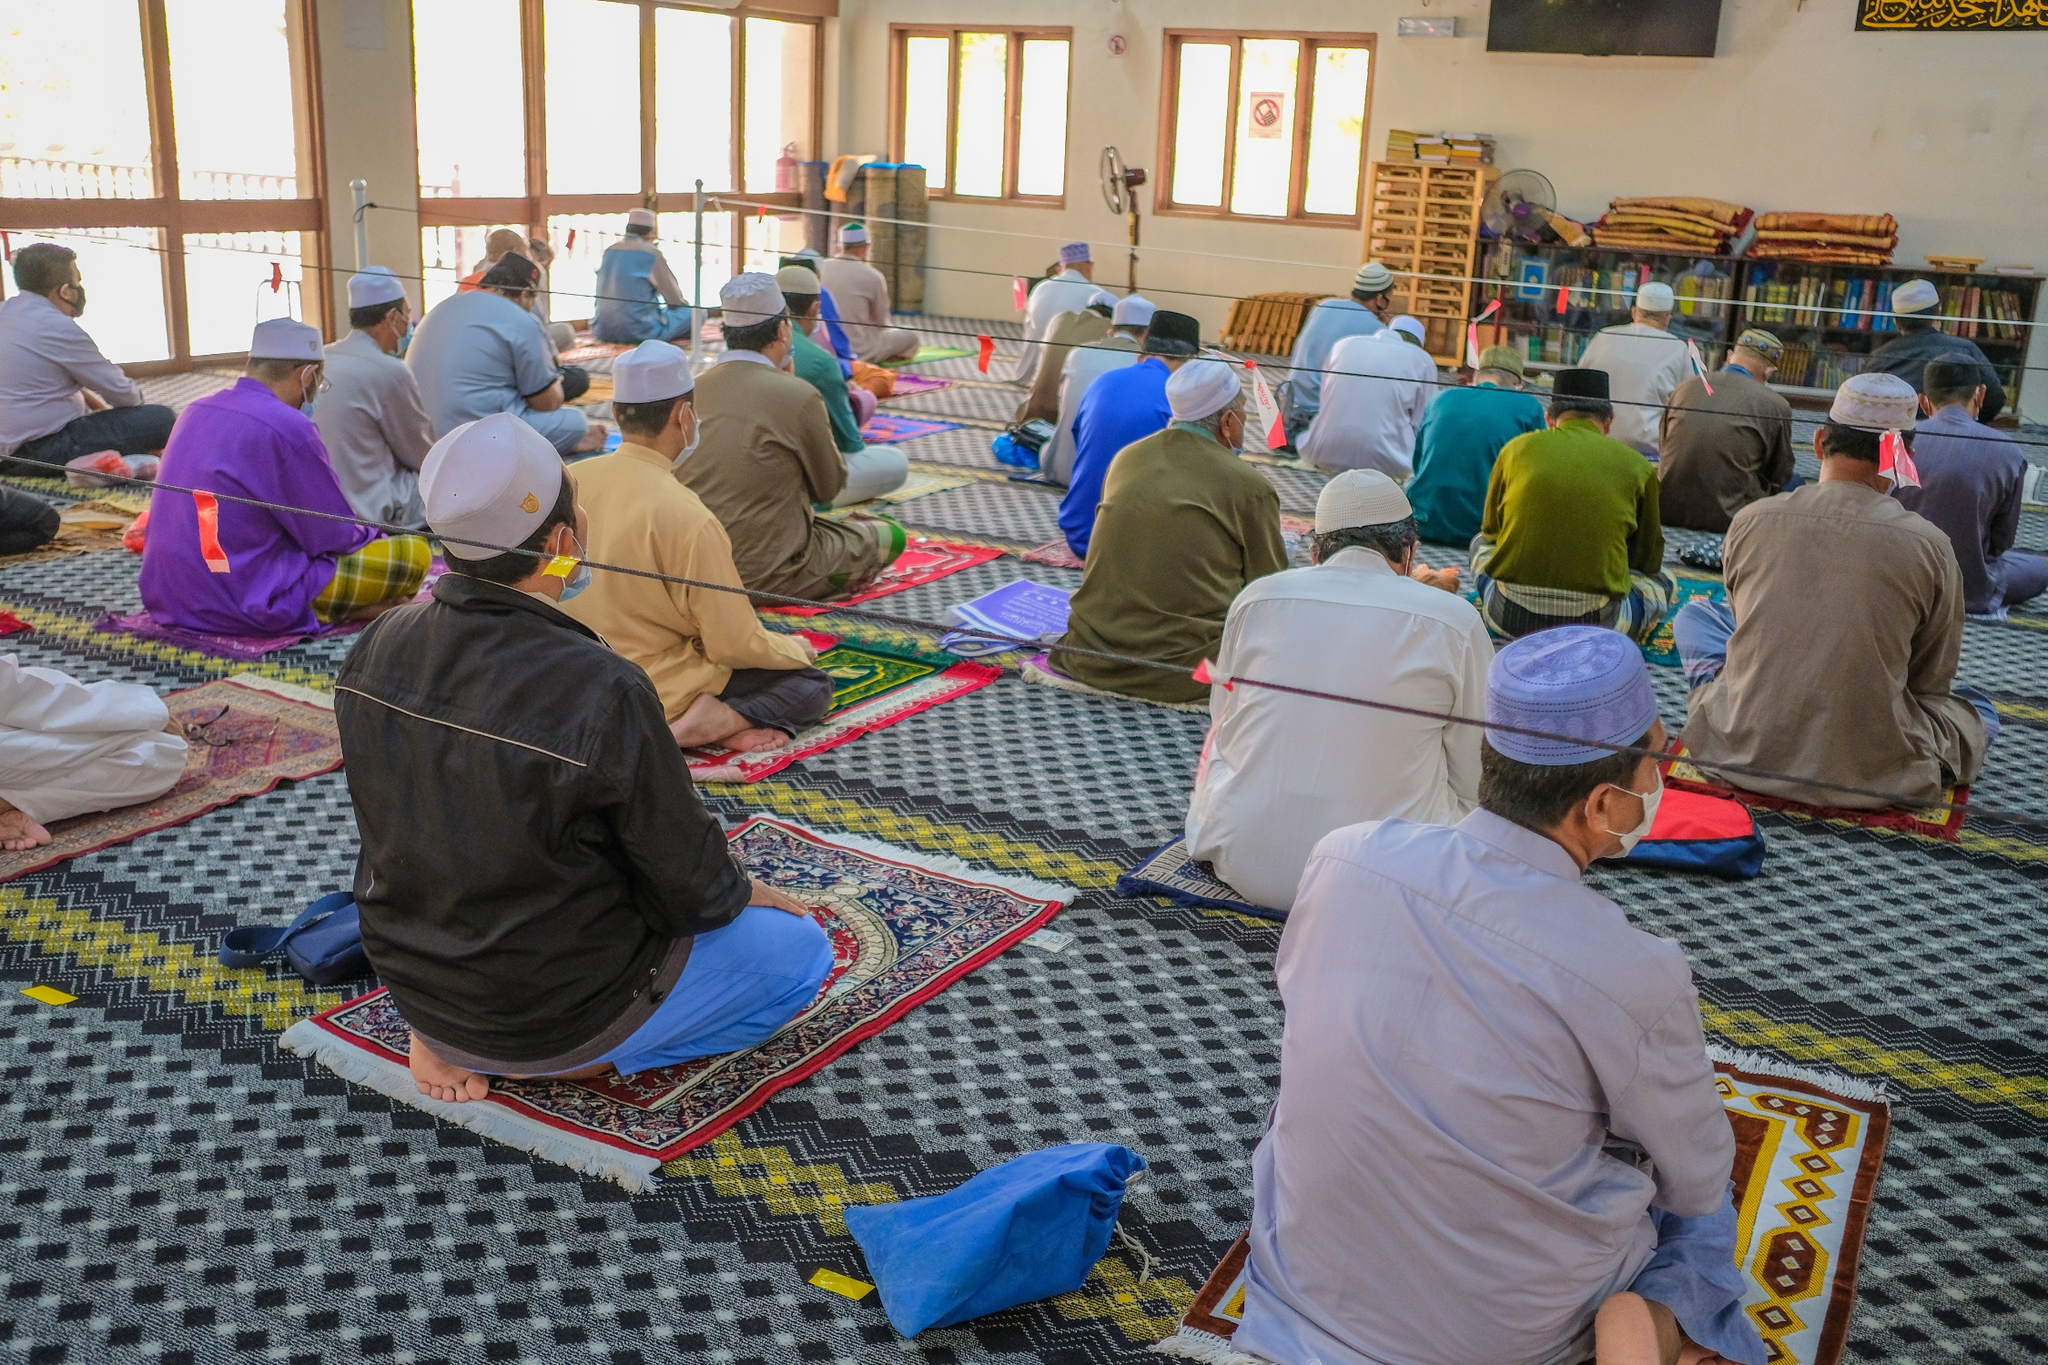Can you elaborate on the elements of the picture provided? The image captures a serene moment inside a mosque. From a high vantage point, we see a group of people engaged in prayer, their bodies aligned in the same direction, signifying unity and harmony. They are seated on vibrant prayer rugs that add a splash of color to the scene. The room itself is spacious and well-lit, with sunlight streaming in through large windows. Along the walls, bookshelves filled with books can be seen, indicating a place of knowledge and learning. The overall atmosphere is one of peace, devotion, and community. As for the landmark information "sa_14517", I couldn't find any specific details related to it[^3^]. 